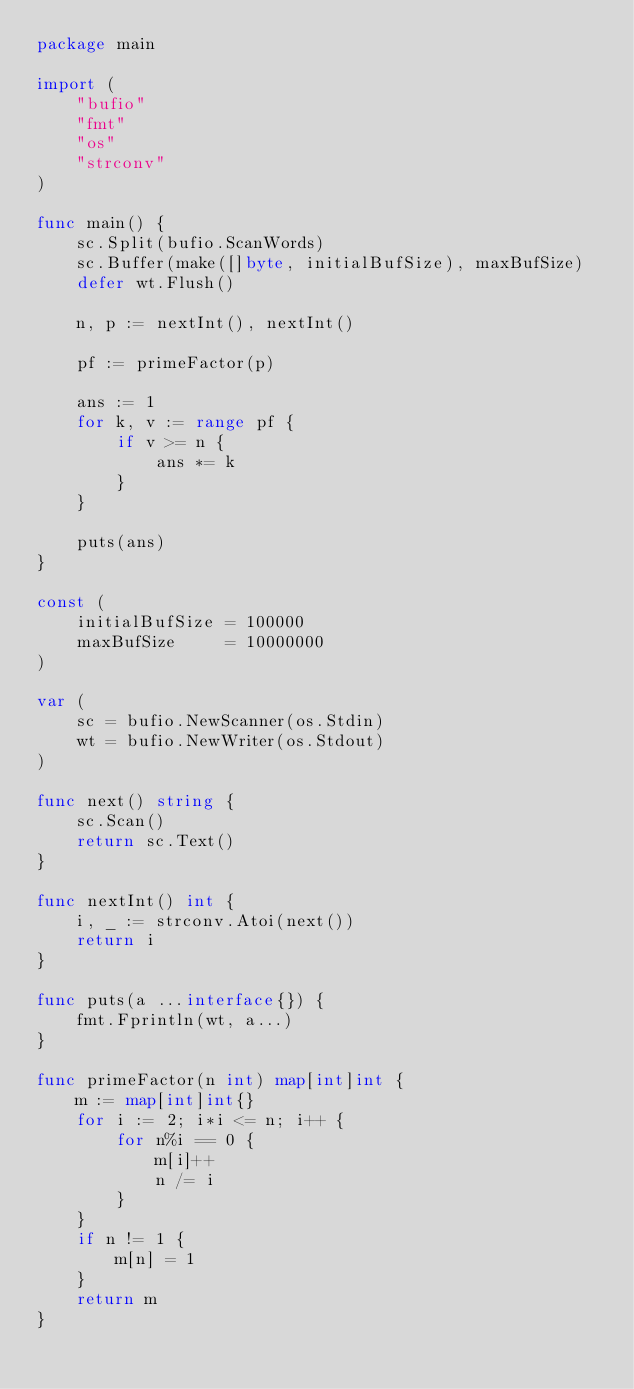<code> <loc_0><loc_0><loc_500><loc_500><_Go_>package main

import (
	"bufio"
	"fmt"
	"os"
	"strconv"
)

func main() {
	sc.Split(bufio.ScanWords)
	sc.Buffer(make([]byte, initialBufSize), maxBufSize)
	defer wt.Flush()

	n, p := nextInt(), nextInt()

	pf := primeFactor(p)

	ans := 1
	for k, v := range pf {
		if v >= n {
			ans *= k
		}
	}

	puts(ans)
}

const (
	initialBufSize = 100000
	maxBufSize     = 10000000
)

var (
	sc = bufio.NewScanner(os.Stdin)
	wt = bufio.NewWriter(os.Stdout)
)

func next() string {
	sc.Scan()
	return sc.Text()
}

func nextInt() int {
	i, _ := strconv.Atoi(next())
	return i
}

func puts(a ...interface{}) {
	fmt.Fprintln(wt, a...)
}

func primeFactor(n int) map[int]int {
	m := map[int]int{}
	for i := 2; i*i <= n; i++ {
		for n%i == 0 {
			m[i]++
			n /= i
		}
	}
	if n != 1 {
		m[n] = 1
	}
	return m
}
</code> 